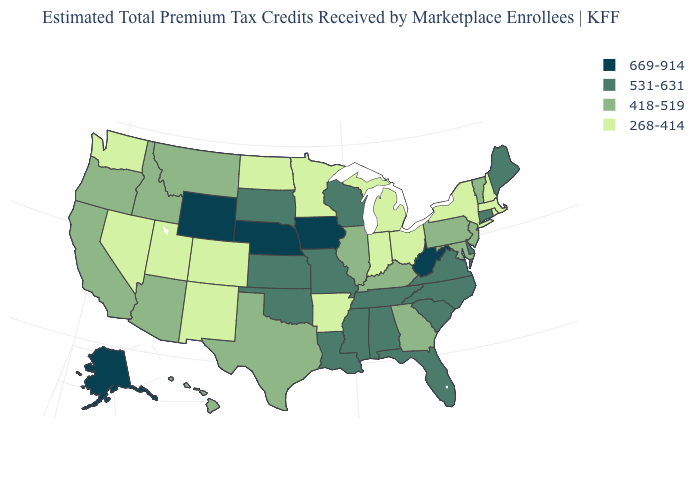What is the lowest value in the West?
Keep it brief. 268-414. Name the states that have a value in the range 268-414?
Concise answer only. Arkansas, Colorado, Indiana, Massachusetts, Michigan, Minnesota, Nevada, New Hampshire, New Mexico, New York, North Dakota, Ohio, Rhode Island, Utah, Washington. Does Kentucky have the same value as Hawaii?
Answer briefly. Yes. What is the value of Indiana?
Give a very brief answer. 268-414. Does the first symbol in the legend represent the smallest category?
Give a very brief answer. No. What is the lowest value in the West?
Short answer required. 268-414. What is the value of Kansas?
Keep it brief. 531-631. What is the lowest value in the USA?
Answer briefly. 268-414. Among the states that border Maine , which have the highest value?
Concise answer only. New Hampshire. Which states hav the highest value in the MidWest?
Short answer required. Iowa, Nebraska. What is the highest value in the MidWest ?
Give a very brief answer. 669-914. What is the lowest value in the West?
Answer briefly. 268-414. What is the highest value in states that border New Mexico?
Answer briefly. 531-631. Does South Dakota have the same value as Hawaii?
Be succinct. No. Which states have the highest value in the USA?
Write a very short answer. Alaska, Iowa, Nebraska, West Virginia, Wyoming. 